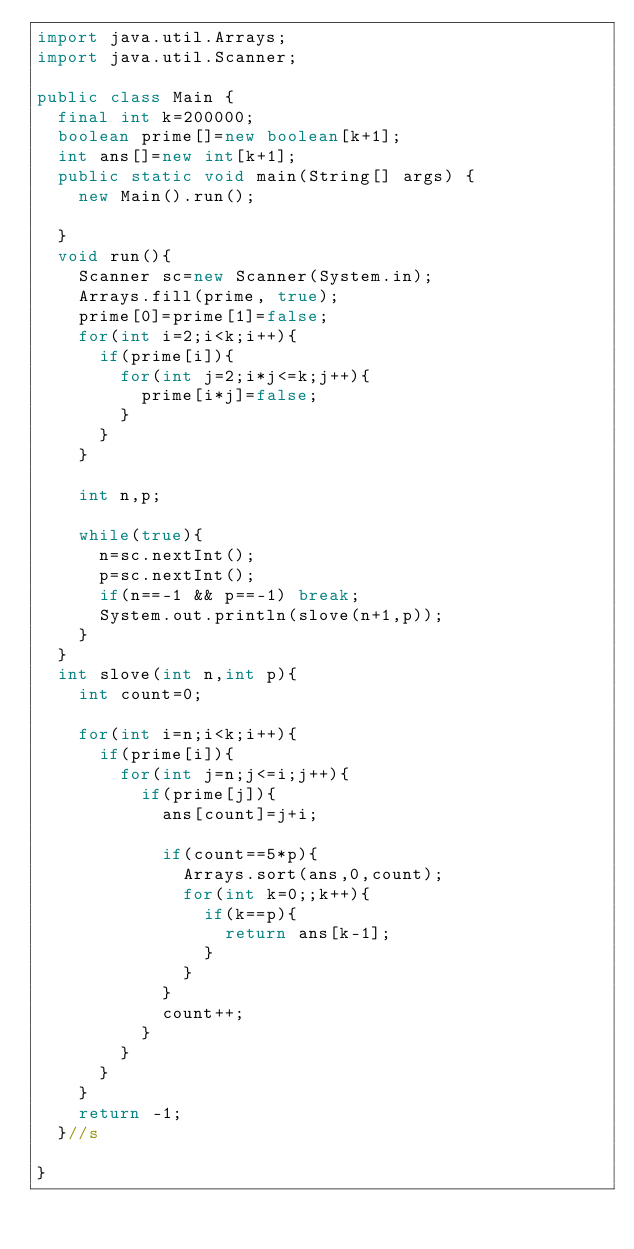<code> <loc_0><loc_0><loc_500><loc_500><_Java_>import java.util.Arrays;
import java.util.Scanner;

public class Main {
	final int k=200000;
	boolean prime[]=new boolean[k+1];
	int ans[]=new int[k+1];
	public static void main(String[] args) {
		new Main().run();

	}
	void run(){
		Scanner sc=new Scanner(System.in);
		Arrays.fill(prime, true);
		prime[0]=prime[1]=false;
		for(int i=2;i<k;i++){
			if(prime[i]){
				for(int j=2;i*j<=k;j++){
					prime[i*j]=false;
				}
			}
		}

		int n,p;

		while(true){
			n=sc.nextInt();
			p=sc.nextInt();
			if(n==-1 && p==-1) break;
			System.out.println(slove(n+1,p));
		}
	}
	int slove(int n,int p){
		int count=0;

		for(int i=n;i<k;i++){
			if(prime[i]){
				for(int j=n;j<=i;j++){
					if(prime[j]){
						ans[count]=j+i;
						
						if(count==5*p){
							Arrays.sort(ans,0,count);
							for(int k=0;;k++){
								if(k==p){
									return ans[k-1];
								}
							}
						}
						count++;
					}
				}
			}
		}
		return -1;
	}//s

}</code> 